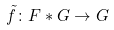Convert formula to latex. <formula><loc_0><loc_0><loc_500><loc_500>\tilde { f } \colon F * G \rightarrow G</formula> 